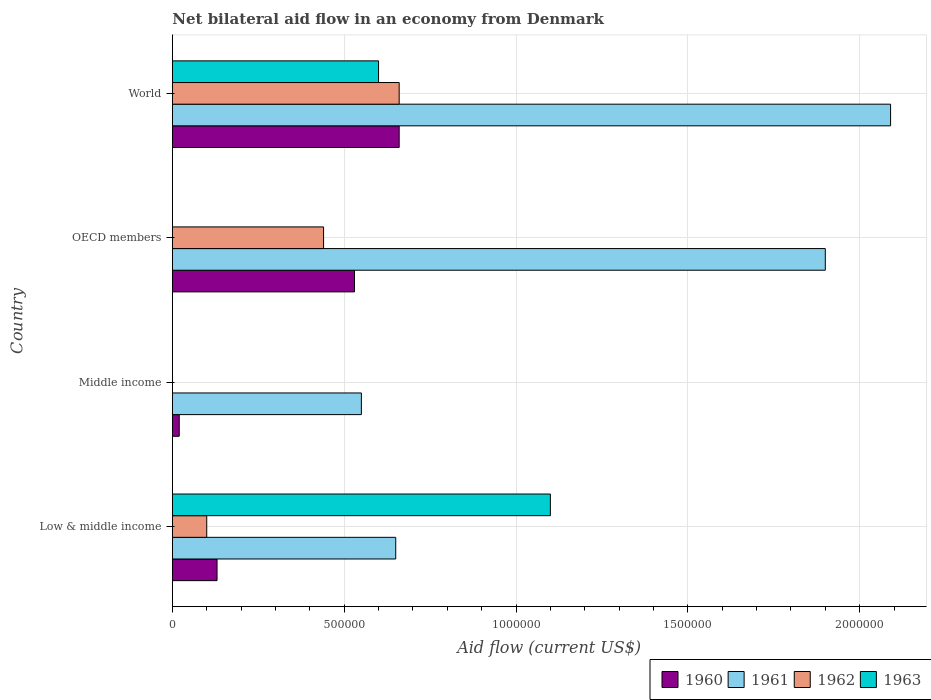How many bars are there on the 2nd tick from the bottom?
Provide a short and direct response. 2. In how many cases, is the number of bars for a given country not equal to the number of legend labels?
Ensure brevity in your answer.  2. Across all countries, what is the maximum net bilateral aid flow in 1963?
Make the answer very short. 1.10e+06. Across all countries, what is the minimum net bilateral aid flow in 1962?
Ensure brevity in your answer.  0. What is the total net bilateral aid flow in 1960 in the graph?
Your answer should be compact. 1.34e+06. What is the difference between the net bilateral aid flow in 1960 in Low & middle income and that in OECD members?
Your answer should be compact. -4.00e+05. What is the difference between the net bilateral aid flow in 1960 in OECD members and the net bilateral aid flow in 1962 in Middle income?
Keep it short and to the point. 5.30e+05. In how many countries, is the net bilateral aid flow in 1962 greater than 900000 US$?
Your response must be concise. 0. What is the ratio of the net bilateral aid flow in 1962 in OECD members to that in World?
Keep it short and to the point. 0.67. Is the net bilateral aid flow in 1961 in Middle income less than that in World?
Offer a terse response. Yes. What is the difference between the highest and the second highest net bilateral aid flow in 1961?
Give a very brief answer. 1.90e+05. What is the difference between the highest and the lowest net bilateral aid flow in 1961?
Offer a terse response. 1.54e+06. In how many countries, is the net bilateral aid flow in 1961 greater than the average net bilateral aid flow in 1961 taken over all countries?
Give a very brief answer. 2. Is the sum of the net bilateral aid flow in 1960 in Middle income and OECD members greater than the maximum net bilateral aid flow in 1961 across all countries?
Offer a terse response. No. Is it the case that in every country, the sum of the net bilateral aid flow in 1960 and net bilateral aid flow in 1963 is greater than the sum of net bilateral aid flow in 1961 and net bilateral aid flow in 1962?
Provide a succinct answer. No. Is it the case that in every country, the sum of the net bilateral aid flow in 1961 and net bilateral aid flow in 1963 is greater than the net bilateral aid flow in 1960?
Provide a succinct answer. Yes. How many bars are there?
Ensure brevity in your answer.  13. Are all the bars in the graph horizontal?
Your answer should be very brief. Yes. How many countries are there in the graph?
Ensure brevity in your answer.  4. What is the difference between two consecutive major ticks on the X-axis?
Offer a very short reply. 5.00e+05. Are the values on the major ticks of X-axis written in scientific E-notation?
Your answer should be very brief. No. Where does the legend appear in the graph?
Provide a short and direct response. Bottom right. What is the title of the graph?
Provide a succinct answer. Net bilateral aid flow in an economy from Denmark. What is the label or title of the Y-axis?
Give a very brief answer. Country. What is the Aid flow (current US$) in 1960 in Low & middle income?
Keep it short and to the point. 1.30e+05. What is the Aid flow (current US$) in 1961 in Low & middle income?
Give a very brief answer. 6.50e+05. What is the Aid flow (current US$) of 1962 in Low & middle income?
Your answer should be compact. 1.00e+05. What is the Aid flow (current US$) of 1963 in Low & middle income?
Ensure brevity in your answer.  1.10e+06. What is the Aid flow (current US$) of 1960 in Middle income?
Make the answer very short. 2.00e+04. What is the Aid flow (current US$) of 1961 in Middle income?
Make the answer very short. 5.50e+05. What is the Aid flow (current US$) in 1962 in Middle income?
Provide a short and direct response. 0. What is the Aid flow (current US$) of 1960 in OECD members?
Your response must be concise. 5.30e+05. What is the Aid flow (current US$) of 1961 in OECD members?
Give a very brief answer. 1.90e+06. What is the Aid flow (current US$) in 1963 in OECD members?
Provide a short and direct response. 0. What is the Aid flow (current US$) in 1960 in World?
Make the answer very short. 6.60e+05. What is the Aid flow (current US$) in 1961 in World?
Offer a very short reply. 2.09e+06. What is the Aid flow (current US$) of 1962 in World?
Keep it short and to the point. 6.60e+05. What is the Aid flow (current US$) in 1963 in World?
Your answer should be compact. 6.00e+05. Across all countries, what is the maximum Aid flow (current US$) of 1960?
Your answer should be very brief. 6.60e+05. Across all countries, what is the maximum Aid flow (current US$) of 1961?
Ensure brevity in your answer.  2.09e+06. Across all countries, what is the maximum Aid flow (current US$) of 1963?
Your answer should be compact. 1.10e+06. Across all countries, what is the minimum Aid flow (current US$) of 1961?
Provide a succinct answer. 5.50e+05. What is the total Aid flow (current US$) of 1960 in the graph?
Offer a very short reply. 1.34e+06. What is the total Aid flow (current US$) of 1961 in the graph?
Your answer should be very brief. 5.19e+06. What is the total Aid flow (current US$) in 1962 in the graph?
Make the answer very short. 1.20e+06. What is the total Aid flow (current US$) in 1963 in the graph?
Give a very brief answer. 1.70e+06. What is the difference between the Aid flow (current US$) of 1961 in Low & middle income and that in Middle income?
Your answer should be compact. 1.00e+05. What is the difference between the Aid flow (current US$) in 1960 in Low & middle income and that in OECD members?
Your answer should be very brief. -4.00e+05. What is the difference between the Aid flow (current US$) in 1961 in Low & middle income and that in OECD members?
Offer a very short reply. -1.25e+06. What is the difference between the Aid flow (current US$) of 1962 in Low & middle income and that in OECD members?
Offer a very short reply. -3.40e+05. What is the difference between the Aid flow (current US$) of 1960 in Low & middle income and that in World?
Provide a short and direct response. -5.30e+05. What is the difference between the Aid flow (current US$) in 1961 in Low & middle income and that in World?
Provide a short and direct response. -1.44e+06. What is the difference between the Aid flow (current US$) in 1962 in Low & middle income and that in World?
Your response must be concise. -5.60e+05. What is the difference between the Aid flow (current US$) in 1960 in Middle income and that in OECD members?
Offer a terse response. -5.10e+05. What is the difference between the Aid flow (current US$) in 1961 in Middle income and that in OECD members?
Offer a very short reply. -1.35e+06. What is the difference between the Aid flow (current US$) of 1960 in Middle income and that in World?
Keep it short and to the point. -6.40e+05. What is the difference between the Aid flow (current US$) of 1961 in Middle income and that in World?
Offer a terse response. -1.54e+06. What is the difference between the Aid flow (current US$) of 1960 in OECD members and that in World?
Your answer should be compact. -1.30e+05. What is the difference between the Aid flow (current US$) in 1961 in OECD members and that in World?
Your response must be concise. -1.90e+05. What is the difference between the Aid flow (current US$) of 1962 in OECD members and that in World?
Your answer should be compact. -2.20e+05. What is the difference between the Aid flow (current US$) in 1960 in Low & middle income and the Aid flow (current US$) in 1961 in Middle income?
Provide a short and direct response. -4.20e+05. What is the difference between the Aid flow (current US$) of 1960 in Low & middle income and the Aid flow (current US$) of 1961 in OECD members?
Offer a very short reply. -1.77e+06. What is the difference between the Aid flow (current US$) in 1960 in Low & middle income and the Aid flow (current US$) in 1962 in OECD members?
Your response must be concise. -3.10e+05. What is the difference between the Aid flow (current US$) in 1960 in Low & middle income and the Aid flow (current US$) in 1961 in World?
Your response must be concise. -1.96e+06. What is the difference between the Aid flow (current US$) of 1960 in Low & middle income and the Aid flow (current US$) of 1962 in World?
Your answer should be compact. -5.30e+05. What is the difference between the Aid flow (current US$) of 1960 in Low & middle income and the Aid flow (current US$) of 1963 in World?
Offer a very short reply. -4.70e+05. What is the difference between the Aid flow (current US$) in 1961 in Low & middle income and the Aid flow (current US$) in 1962 in World?
Make the answer very short. -10000. What is the difference between the Aid flow (current US$) in 1961 in Low & middle income and the Aid flow (current US$) in 1963 in World?
Keep it short and to the point. 5.00e+04. What is the difference between the Aid flow (current US$) in 1962 in Low & middle income and the Aid flow (current US$) in 1963 in World?
Keep it short and to the point. -5.00e+05. What is the difference between the Aid flow (current US$) of 1960 in Middle income and the Aid flow (current US$) of 1961 in OECD members?
Provide a short and direct response. -1.88e+06. What is the difference between the Aid flow (current US$) in 1960 in Middle income and the Aid flow (current US$) in 1962 in OECD members?
Keep it short and to the point. -4.20e+05. What is the difference between the Aid flow (current US$) in 1961 in Middle income and the Aid flow (current US$) in 1962 in OECD members?
Make the answer very short. 1.10e+05. What is the difference between the Aid flow (current US$) in 1960 in Middle income and the Aid flow (current US$) in 1961 in World?
Ensure brevity in your answer.  -2.07e+06. What is the difference between the Aid flow (current US$) in 1960 in Middle income and the Aid flow (current US$) in 1962 in World?
Make the answer very short. -6.40e+05. What is the difference between the Aid flow (current US$) in 1960 in Middle income and the Aid flow (current US$) in 1963 in World?
Keep it short and to the point. -5.80e+05. What is the difference between the Aid flow (current US$) in 1960 in OECD members and the Aid flow (current US$) in 1961 in World?
Your response must be concise. -1.56e+06. What is the difference between the Aid flow (current US$) of 1960 in OECD members and the Aid flow (current US$) of 1963 in World?
Offer a very short reply. -7.00e+04. What is the difference between the Aid flow (current US$) in 1961 in OECD members and the Aid flow (current US$) in 1962 in World?
Provide a succinct answer. 1.24e+06. What is the difference between the Aid flow (current US$) of 1961 in OECD members and the Aid flow (current US$) of 1963 in World?
Your answer should be very brief. 1.30e+06. What is the average Aid flow (current US$) of 1960 per country?
Offer a very short reply. 3.35e+05. What is the average Aid flow (current US$) of 1961 per country?
Keep it short and to the point. 1.30e+06. What is the average Aid flow (current US$) of 1963 per country?
Provide a short and direct response. 4.25e+05. What is the difference between the Aid flow (current US$) in 1960 and Aid flow (current US$) in 1961 in Low & middle income?
Provide a succinct answer. -5.20e+05. What is the difference between the Aid flow (current US$) in 1960 and Aid flow (current US$) in 1963 in Low & middle income?
Give a very brief answer. -9.70e+05. What is the difference between the Aid flow (current US$) of 1961 and Aid flow (current US$) of 1963 in Low & middle income?
Offer a terse response. -4.50e+05. What is the difference between the Aid flow (current US$) of 1960 and Aid flow (current US$) of 1961 in Middle income?
Give a very brief answer. -5.30e+05. What is the difference between the Aid flow (current US$) in 1960 and Aid flow (current US$) in 1961 in OECD members?
Your answer should be compact. -1.37e+06. What is the difference between the Aid flow (current US$) in 1961 and Aid flow (current US$) in 1962 in OECD members?
Make the answer very short. 1.46e+06. What is the difference between the Aid flow (current US$) of 1960 and Aid flow (current US$) of 1961 in World?
Offer a terse response. -1.43e+06. What is the difference between the Aid flow (current US$) of 1961 and Aid flow (current US$) of 1962 in World?
Make the answer very short. 1.43e+06. What is the difference between the Aid flow (current US$) of 1961 and Aid flow (current US$) of 1963 in World?
Make the answer very short. 1.49e+06. What is the ratio of the Aid flow (current US$) in 1961 in Low & middle income to that in Middle income?
Keep it short and to the point. 1.18. What is the ratio of the Aid flow (current US$) of 1960 in Low & middle income to that in OECD members?
Keep it short and to the point. 0.25. What is the ratio of the Aid flow (current US$) of 1961 in Low & middle income to that in OECD members?
Give a very brief answer. 0.34. What is the ratio of the Aid flow (current US$) of 1962 in Low & middle income to that in OECD members?
Keep it short and to the point. 0.23. What is the ratio of the Aid flow (current US$) of 1960 in Low & middle income to that in World?
Your answer should be very brief. 0.2. What is the ratio of the Aid flow (current US$) of 1961 in Low & middle income to that in World?
Offer a terse response. 0.31. What is the ratio of the Aid flow (current US$) of 1962 in Low & middle income to that in World?
Provide a succinct answer. 0.15. What is the ratio of the Aid flow (current US$) in 1963 in Low & middle income to that in World?
Your response must be concise. 1.83. What is the ratio of the Aid flow (current US$) in 1960 in Middle income to that in OECD members?
Your answer should be very brief. 0.04. What is the ratio of the Aid flow (current US$) of 1961 in Middle income to that in OECD members?
Your response must be concise. 0.29. What is the ratio of the Aid flow (current US$) in 1960 in Middle income to that in World?
Provide a succinct answer. 0.03. What is the ratio of the Aid flow (current US$) of 1961 in Middle income to that in World?
Your response must be concise. 0.26. What is the ratio of the Aid flow (current US$) in 1960 in OECD members to that in World?
Give a very brief answer. 0.8. What is the ratio of the Aid flow (current US$) of 1961 in OECD members to that in World?
Provide a short and direct response. 0.91. What is the difference between the highest and the second highest Aid flow (current US$) in 1960?
Provide a short and direct response. 1.30e+05. What is the difference between the highest and the lowest Aid flow (current US$) of 1960?
Your answer should be very brief. 6.40e+05. What is the difference between the highest and the lowest Aid flow (current US$) of 1961?
Your answer should be very brief. 1.54e+06. What is the difference between the highest and the lowest Aid flow (current US$) in 1963?
Your answer should be very brief. 1.10e+06. 